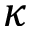<formula> <loc_0><loc_0><loc_500><loc_500>\kappa</formula> 